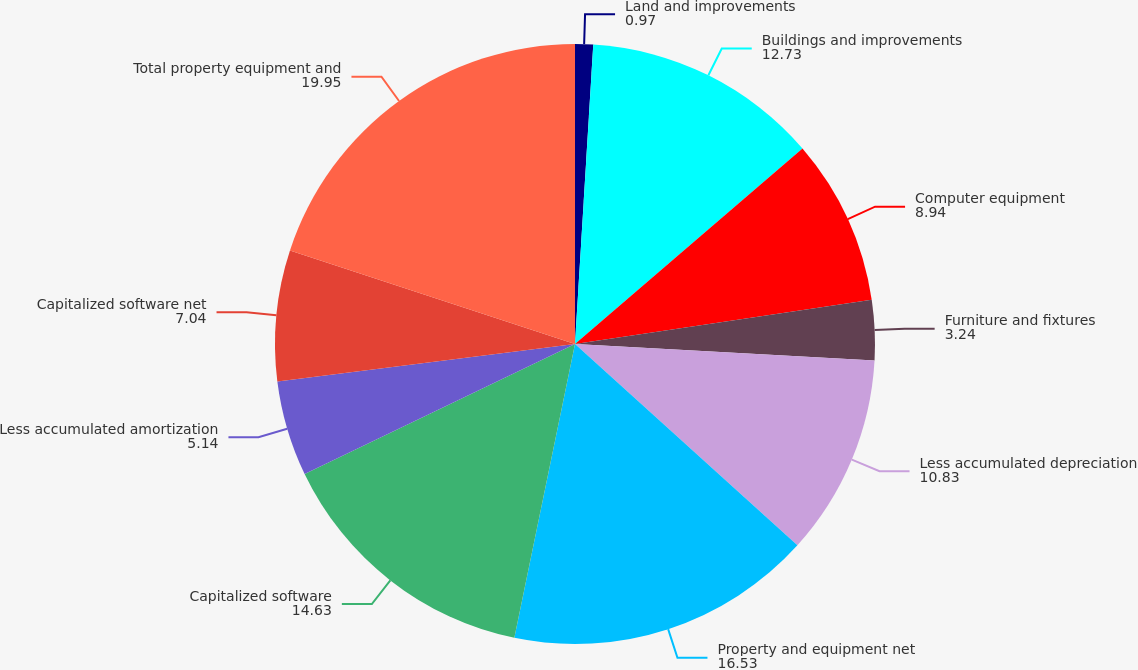<chart> <loc_0><loc_0><loc_500><loc_500><pie_chart><fcel>Land and improvements<fcel>Buildings and improvements<fcel>Computer equipment<fcel>Furniture and fixtures<fcel>Less accumulated depreciation<fcel>Property and equipment net<fcel>Capitalized software<fcel>Less accumulated amortization<fcel>Capitalized software net<fcel>Total property equipment and<nl><fcel>0.97%<fcel>12.73%<fcel>8.94%<fcel>3.24%<fcel>10.83%<fcel>16.53%<fcel>14.63%<fcel>5.14%<fcel>7.04%<fcel>19.95%<nl></chart> 